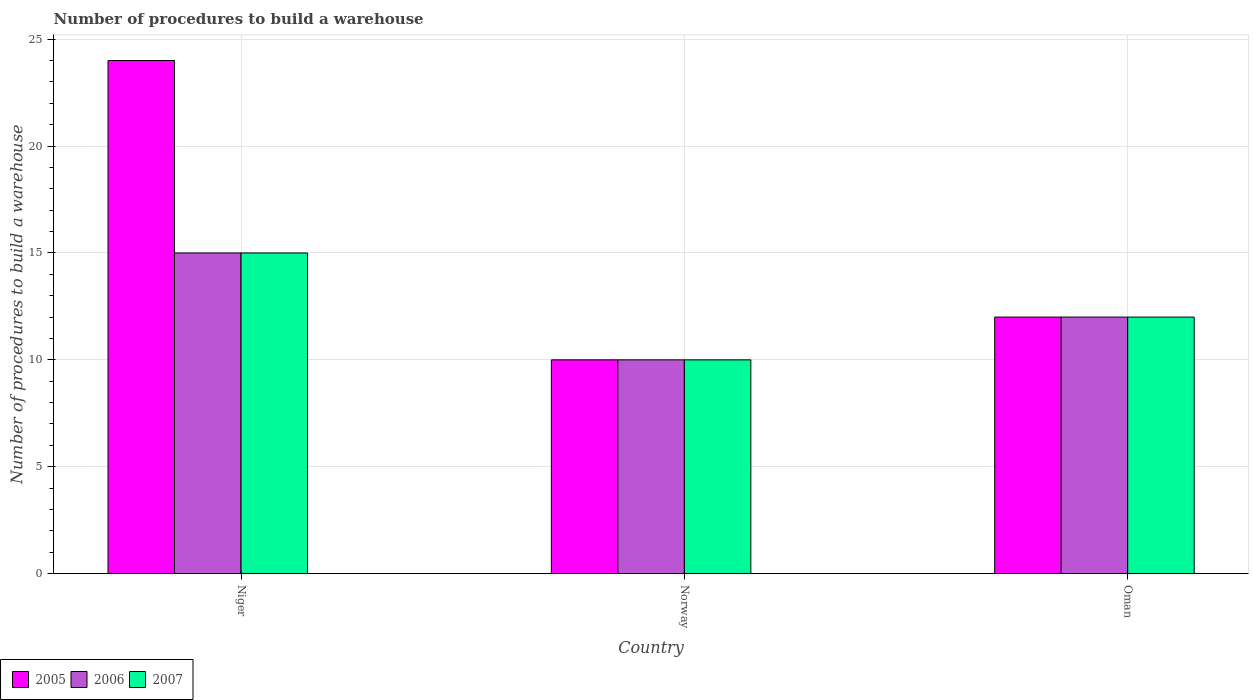Are the number of bars per tick equal to the number of legend labels?
Provide a succinct answer. Yes. How many bars are there on the 2nd tick from the left?
Give a very brief answer. 3. What is the label of the 1st group of bars from the left?
Give a very brief answer. Niger. In which country was the number of procedures to build a warehouse in in 2006 maximum?
Ensure brevity in your answer.  Niger. In which country was the number of procedures to build a warehouse in in 2006 minimum?
Give a very brief answer. Norway. What is the average number of procedures to build a warehouse in in 2005 per country?
Your response must be concise. 15.33. In how many countries, is the number of procedures to build a warehouse in in 2005 greater than 9?
Provide a short and direct response. 3. What is the difference between the highest and the second highest number of procedures to build a warehouse in in 2006?
Provide a short and direct response. -2. What is the difference between the highest and the lowest number of procedures to build a warehouse in in 2005?
Make the answer very short. 14. What does the 2nd bar from the left in Oman represents?
Offer a terse response. 2006. Is it the case that in every country, the sum of the number of procedures to build a warehouse in in 2005 and number of procedures to build a warehouse in in 2006 is greater than the number of procedures to build a warehouse in in 2007?
Provide a succinct answer. Yes. How many bars are there?
Offer a terse response. 9. Are all the bars in the graph horizontal?
Ensure brevity in your answer.  No. How many countries are there in the graph?
Your response must be concise. 3. Does the graph contain grids?
Make the answer very short. Yes. What is the title of the graph?
Provide a short and direct response. Number of procedures to build a warehouse. Does "2011" appear as one of the legend labels in the graph?
Your answer should be very brief. No. What is the label or title of the X-axis?
Keep it short and to the point. Country. What is the label or title of the Y-axis?
Provide a short and direct response. Number of procedures to build a warehouse. What is the Number of procedures to build a warehouse of 2007 in Norway?
Keep it short and to the point. 10. What is the Number of procedures to build a warehouse in 2005 in Oman?
Give a very brief answer. 12. What is the Number of procedures to build a warehouse of 2007 in Oman?
Your response must be concise. 12. Across all countries, what is the maximum Number of procedures to build a warehouse in 2006?
Offer a terse response. 15. Across all countries, what is the maximum Number of procedures to build a warehouse of 2007?
Your answer should be very brief. 15. Across all countries, what is the minimum Number of procedures to build a warehouse of 2005?
Keep it short and to the point. 10. Across all countries, what is the minimum Number of procedures to build a warehouse of 2006?
Make the answer very short. 10. Across all countries, what is the minimum Number of procedures to build a warehouse in 2007?
Your response must be concise. 10. What is the total Number of procedures to build a warehouse in 2006 in the graph?
Ensure brevity in your answer.  37. What is the difference between the Number of procedures to build a warehouse of 2005 in Niger and that in Norway?
Make the answer very short. 14. What is the difference between the Number of procedures to build a warehouse in 2007 in Niger and that in Norway?
Provide a succinct answer. 5. What is the difference between the Number of procedures to build a warehouse in 2007 in Niger and that in Oman?
Your answer should be compact. 3. What is the difference between the Number of procedures to build a warehouse in 2005 in Norway and that in Oman?
Provide a short and direct response. -2. What is the difference between the Number of procedures to build a warehouse of 2005 in Niger and the Number of procedures to build a warehouse of 2006 in Norway?
Keep it short and to the point. 14. What is the difference between the Number of procedures to build a warehouse in 2005 in Niger and the Number of procedures to build a warehouse in 2007 in Norway?
Offer a terse response. 14. What is the difference between the Number of procedures to build a warehouse in 2005 in Norway and the Number of procedures to build a warehouse in 2006 in Oman?
Give a very brief answer. -2. What is the difference between the Number of procedures to build a warehouse in 2006 in Norway and the Number of procedures to build a warehouse in 2007 in Oman?
Keep it short and to the point. -2. What is the average Number of procedures to build a warehouse of 2005 per country?
Make the answer very short. 15.33. What is the average Number of procedures to build a warehouse in 2006 per country?
Offer a very short reply. 12.33. What is the average Number of procedures to build a warehouse in 2007 per country?
Your answer should be very brief. 12.33. What is the difference between the Number of procedures to build a warehouse of 2005 and Number of procedures to build a warehouse of 2006 in Niger?
Give a very brief answer. 9. What is the difference between the Number of procedures to build a warehouse in 2005 and Number of procedures to build a warehouse in 2007 in Niger?
Offer a terse response. 9. What is the difference between the Number of procedures to build a warehouse of 2006 and Number of procedures to build a warehouse of 2007 in Niger?
Provide a short and direct response. 0. What is the difference between the Number of procedures to build a warehouse of 2005 and Number of procedures to build a warehouse of 2007 in Norway?
Keep it short and to the point. 0. What is the difference between the Number of procedures to build a warehouse in 2006 and Number of procedures to build a warehouse in 2007 in Norway?
Provide a succinct answer. 0. What is the difference between the Number of procedures to build a warehouse in 2005 and Number of procedures to build a warehouse in 2006 in Oman?
Offer a terse response. 0. What is the difference between the Number of procedures to build a warehouse in 2006 and Number of procedures to build a warehouse in 2007 in Oman?
Your response must be concise. 0. What is the ratio of the Number of procedures to build a warehouse of 2007 in Niger to that in Norway?
Give a very brief answer. 1.5. What is the ratio of the Number of procedures to build a warehouse of 2006 in Niger to that in Oman?
Keep it short and to the point. 1.25. What is the ratio of the Number of procedures to build a warehouse of 2005 in Norway to that in Oman?
Offer a very short reply. 0.83. What is the difference between the highest and the second highest Number of procedures to build a warehouse in 2005?
Offer a terse response. 12. What is the difference between the highest and the second highest Number of procedures to build a warehouse in 2006?
Your response must be concise. 3. What is the difference between the highest and the lowest Number of procedures to build a warehouse of 2007?
Offer a terse response. 5. 